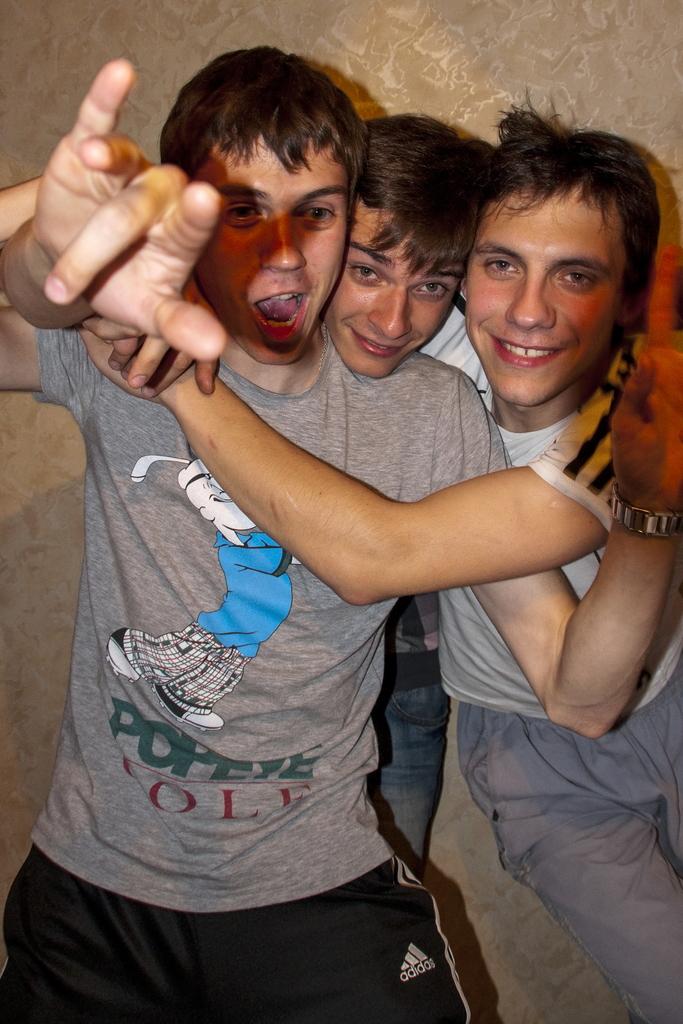What is the character's name playing golf on his shirt?
Provide a short and direct response. Popeye. How many people are in the picture?
Offer a very short reply. Answering does not require reading text in the image. 